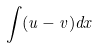<formula> <loc_0><loc_0><loc_500><loc_500>\int ( u - v ) d x</formula> 